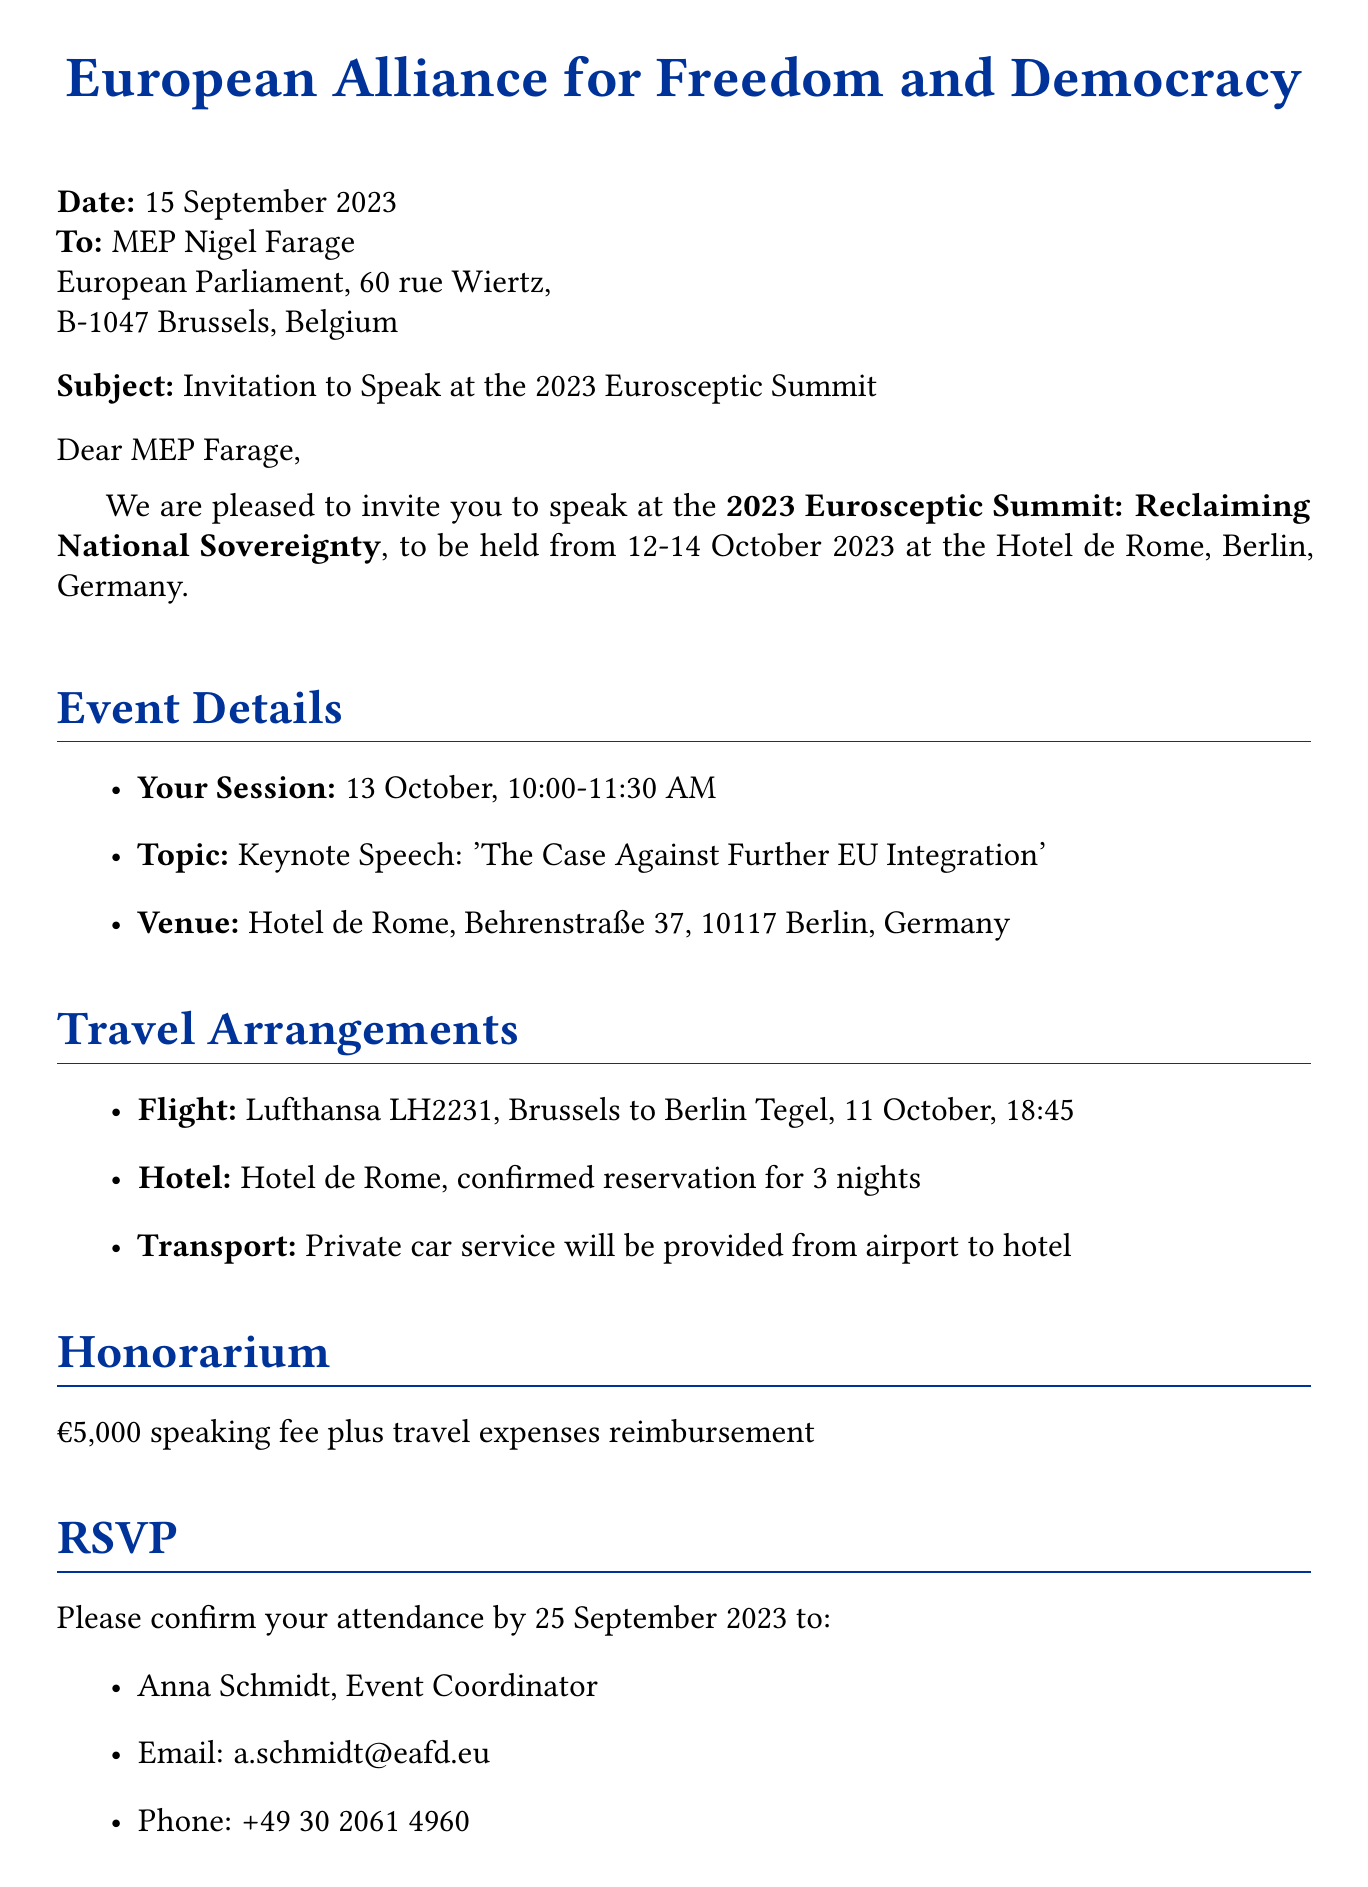what is the date of the event? The event is scheduled for 12-14 October 2023, as mentioned in the document.
Answer: 12-14 October 2023 who is the invitation addressed to? The invitation is addressed to MEP Nigel Farage according to the document.
Answer: MEP Nigel Farage what is the topic of the keynote speech? The document states the topic is 'The Case Against Further EU Integration'.
Answer: The Case Against Further EU Integration what is the honorarium amount? The document specifies an honorarium of €5,000 plus travel expenses reimbursement.
Answer: €5,000 by what date should attendance be confirmed? The RSVP needs to be confirmed by 25 September 2023 as per the document's request.
Answer: 25 September 2023 where will the summit be held? The venue for the summit is Hotel de Rome, Berlin, according to the event details.
Answer: Hotel de Rome, Berlin what service will be provided for transportation? It is mentioned in the document that a private car service will be provided from the airport to the hotel.
Answer: Private car service when will the keynote speech occur? The specific time for the keynote speech is mentioned as 10:00-11:30 AM on 13 October.
Answer: 10:00-11:30 AM on 13 October what flight is arranged? The document specifies the flight as Lufthansa LH2231 from Brussels to Berlin Tegel.
Answer: Lufthansa LH2231 